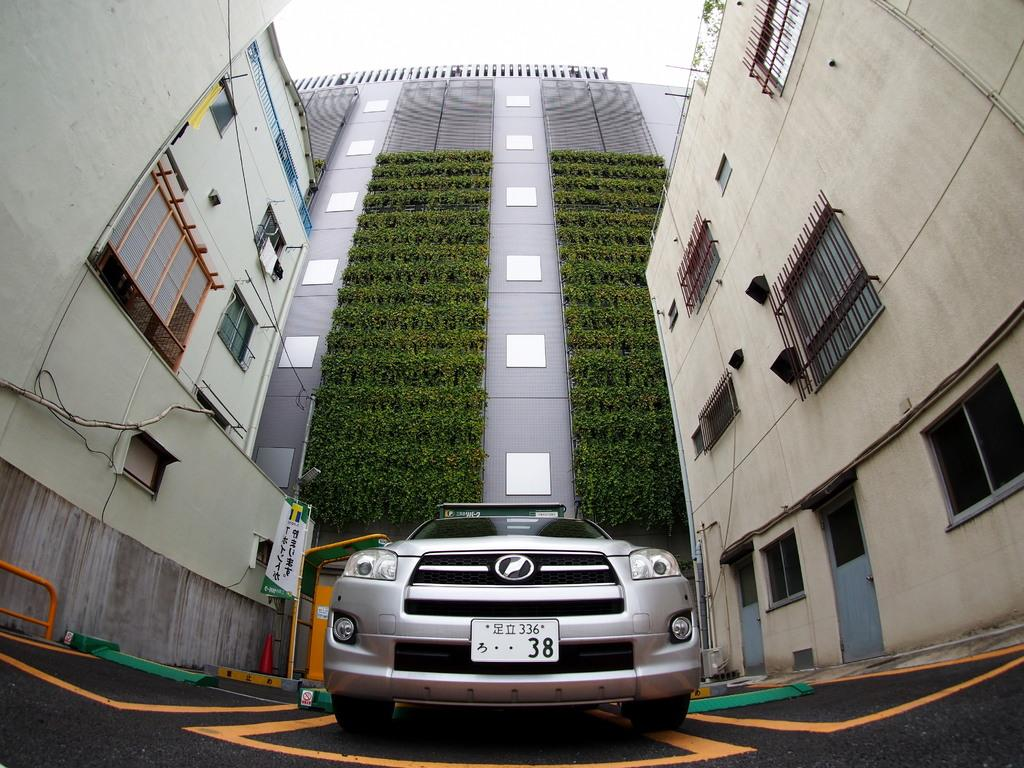What is the main subject of the image? There is a vehicle in the image. What can be seen to the left of the vehicle? There are boards to the left of the vehicle. What is visible in the background of the image? There are buildings with windows and plants in the background of the image. What part of the natural environment is visible in the image? The sky is visible in the background of the image. What type of eggnog is being served at the event in the image? There is no event or eggnog present in the image; it features a vehicle with boards to the left and a background with buildings, plants, and the sky. What type of brush is being used to paint the vehicle in the image? There is no brush or painting activity present in the image; it features a vehicle with boards to the left and a background with buildings, plants, and the sky. 